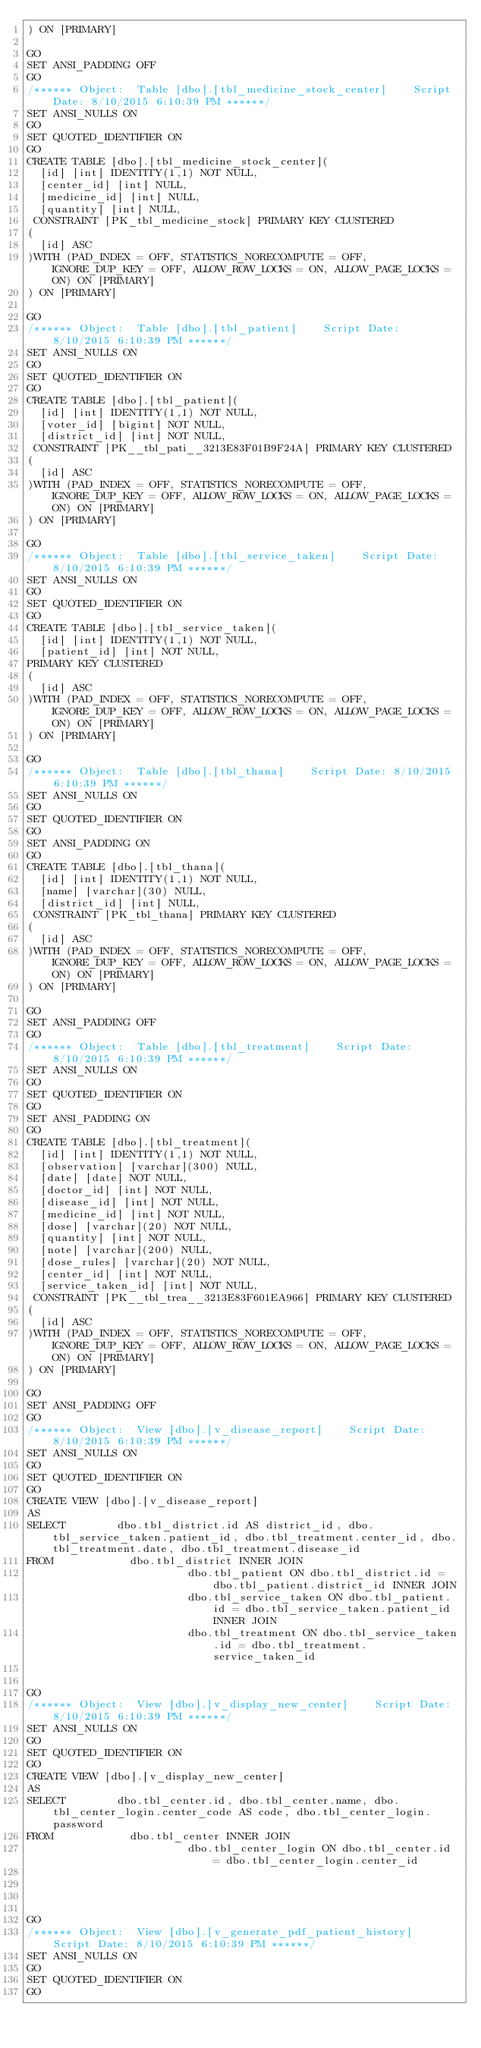Convert code to text. <code><loc_0><loc_0><loc_500><loc_500><_SQL_>) ON [PRIMARY]

GO
SET ANSI_PADDING OFF
GO
/****** Object:  Table [dbo].[tbl_medicine_stock_center]    Script Date: 8/10/2015 6:10:39 PM ******/
SET ANSI_NULLS ON
GO
SET QUOTED_IDENTIFIER ON
GO
CREATE TABLE [dbo].[tbl_medicine_stock_center](
	[id] [int] IDENTITY(1,1) NOT NULL,
	[center_id] [int] NULL,
	[medicine_id] [int] NULL,
	[quantity] [int] NULL,
 CONSTRAINT [PK_tbl_medicine_stock] PRIMARY KEY CLUSTERED 
(
	[id] ASC
)WITH (PAD_INDEX = OFF, STATISTICS_NORECOMPUTE = OFF, IGNORE_DUP_KEY = OFF, ALLOW_ROW_LOCKS = ON, ALLOW_PAGE_LOCKS = ON) ON [PRIMARY]
) ON [PRIMARY]

GO
/****** Object:  Table [dbo].[tbl_patient]    Script Date: 8/10/2015 6:10:39 PM ******/
SET ANSI_NULLS ON
GO
SET QUOTED_IDENTIFIER ON
GO
CREATE TABLE [dbo].[tbl_patient](
	[id] [int] IDENTITY(1,1) NOT NULL,
	[voter_id] [bigint] NOT NULL,
	[district_id] [int] NOT NULL,
 CONSTRAINT [PK__tbl_pati__3213E83F01B9F24A] PRIMARY KEY CLUSTERED 
(
	[id] ASC
)WITH (PAD_INDEX = OFF, STATISTICS_NORECOMPUTE = OFF, IGNORE_DUP_KEY = OFF, ALLOW_ROW_LOCKS = ON, ALLOW_PAGE_LOCKS = ON) ON [PRIMARY]
) ON [PRIMARY]

GO
/****** Object:  Table [dbo].[tbl_service_taken]    Script Date: 8/10/2015 6:10:39 PM ******/
SET ANSI_NULLS ON
GO
SET QUOTED_IDENTIFIER ON
GO
CREATE TABLE [dbo].[tbl_service_taken](
	[id] [int] IDENTITY(1,1) NOT NULL,
	[patient_id] [int] NOT NULL,
PRIMARY KEY CLUSTERED 
(
	[id] ASC
)WITH (PAD_INDEX = OFF, STATISTICS_NORECOMPUTE = OFF, IGNORE_DUP_KEY = OFF, ALLOW_ROW_LOCKS = ON, ALLOW_PAGE_LOCKS = ON) ON [PRIMARY]
) ON [PRIMARY]

GO
/****** Object:  Table [dbo].[tbl_thana]    Script Date: 8/10/2015 6:10:39 PM ******/
SET ANSI_NULLS ON
GO
SET QUOTED_IDENTIFIER ON
GO
SET ANSI_PADDING ON
GO
CREATE TABLE [dbo].[tbl_thana](
	[id] [int] IDENTITY(1,1) NOT NULL,
	[name] [varchar](30) NULL,
	[district_id] [int] NULL,
 CONSTRAINT [PK_tbl_thana] PRIMARY KEY CLUSTERED 
(
	[id] ASC
)WITH (PAD_INDEX = OFF, STATISTICS_NORECOMPUTE = OFF, IGNORE_DUP_KEY = OFF, ALLOW_ROW_LOCKS = ON, ALLOW_PAGE_LOCKS = ON) ON [PRIMARY]
) ON [PRIMARY]

GO
SET ANSI_PADDING OFF
GO
/****** Object:  Table [dbo].[tbl_treatment]    Script Date: 8/10/2015 6:10:39 PM ******/
SET ANSI_NULLS ON
GO
SET QUOTED_IDENTIFIER ON
GO
SET ANSI_PADDING ON
GO
CREATE TABLE [dbo].[tbl_treatment](
	[id] [int] IDENTITY(1,1) NOT NULL,
	[observation] [varchar](300) NULL,
	[date] [date] NOT NULL,
	[doctor_id] [int] NOT NULL,
	[disease_id] [int] NOT NULL,
	[medicine_id] [int] NOT NULL,
	[dose] [varchar](20) NOT NULL,
	[quantity] [int] NOT NULL,
	[note] [varchar](200) NULL,
	[dose_rules] [varchar](20) NOT NULL,
	[center_id] [int] NOT NULL,
	[service_taken_id] [int] NOT NULL,
 CONSTRAINT [PK__tbl_trea__3213E83F601EA966] PRIMARY KEY CLUSTERED 
(
	[id] ASC
)WITH (PAD_INDEX = OFF, STATISTICS_NORECOMPUTE = OFF, IGNORE_DUP_KEY = OFF, ALLOW_ROW_LOCKS = ON, ALLOW_PAGE_LOCKS = ON) ON [PRIMARY]
) ON [PRIMARY]

GO
SET ANSI_PADDING OFF
GO
/****** Object:  View [dbo].[v_disease_report]    Script Date: 8/10/2015 6:10:39 PM ******/
SET ANSI_NULLS ON
GO
SET QUOTED_IDENTIFIER ON
GO
CREATE VIEW [dbo].[v_disease_report]
AS
SELECT        dbo.tbl_district.id AS district_id, dbo.tbl_service_taken.patient_id, dbo.tbl_treatment.center_id, dbo.tbl_treatment.date, dbo.tbl_treatment.disease_id
FROM            dbo.tbl_district INNER JOIN
                         dbo.tbl_patient ON dbo.tbl_district.id = dbo.tbl_patient.district_id INNER JOIN
                         dbo.tbl_service_taken ON dbo.tbl_patient.id = dbo.tbl_service_taken.patient_id INNER JOIN
                         dbo.tbl_treatment ON dbo.tbl_service_taken.id = dbo.tbl_treatment.service_taken_id


GO
/****** Object:  View [dbo].[v_display_new_center]    Script Date: 8/10/2015 6:10:39 PM ******/
SET ANSI_NULLS ON
GO
SET QUOTED_IDENTIFIER ON
GO
CREATE VIEW [dbo].[v_display_new_center]
AS
SELECT        dbo.tbl_center.id, dbo.tbl_center.name, dbo.tbl_center_login.center_code AS code, dbo.tbl_center_login.password
FROM            dbo.tbl_center INNER JOIN
                         dbo.tbl_center_login ON dbo.tbl_center.id = dbo.tbl_center_login.center_id




GO
/****** Object:  View [dbo].[v_generate_pdf_patient_history]    Script Date: 8/10/2015 6:10:39 PM ******/
SET ANSI_NULLS ON
GO
SET QUOTED_IDENTIFIER ON
GO</code> 